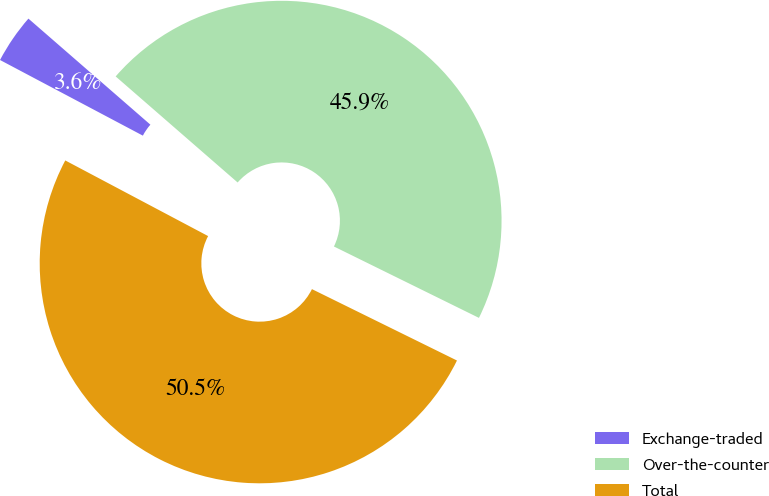Convert chart. <chart><loc_0><loc_0><loc_500><loc_500><pie_chart><fcel>Exchange-traded<fcel>Over-the-counter<fcel>Total<nl><fcel>3.64%<fcel>45.89%<fcel>50.47%<nl></chart> 